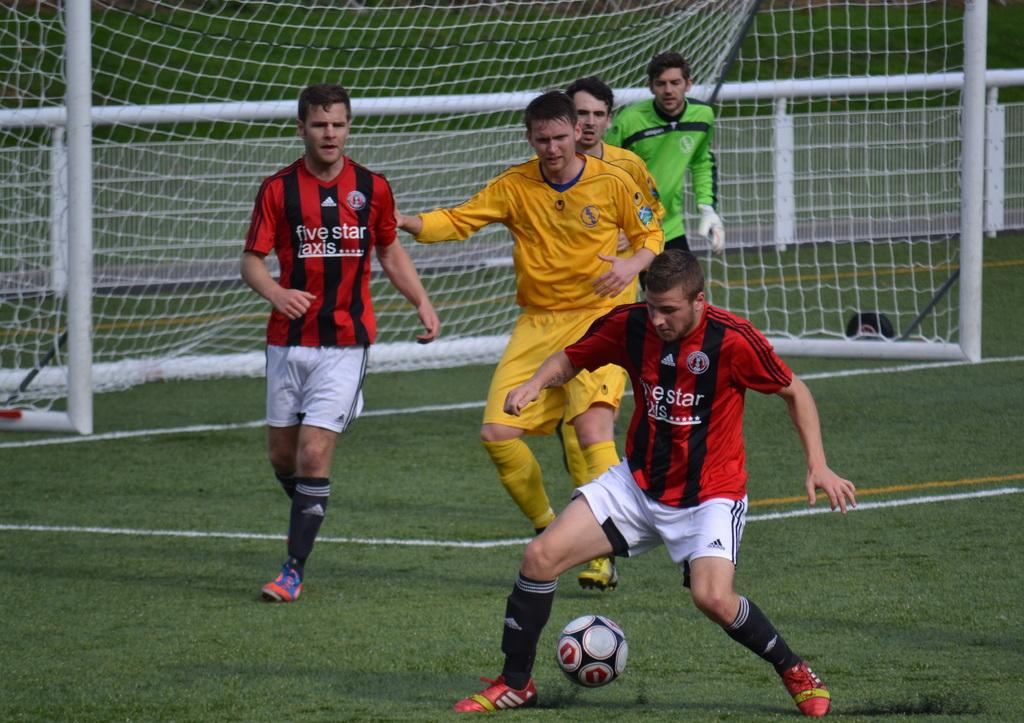What sport are the two teams playing in the image? The two teams are playing football in the image. Where are the teams playing? They are playing on a ground. What object are they using to play the game? They are using a ball to play. Can you describe the presence of a specific player in the image? There is a goalkeeper in the background of the image. What is the main objective of the game in the image? The main objective is to score goals, as indicated by the presence of a goal post in the background of the image. What type of butter is being used to grease the hand of the player in the image? There is no butter or hand-greasing activity present in the image. 